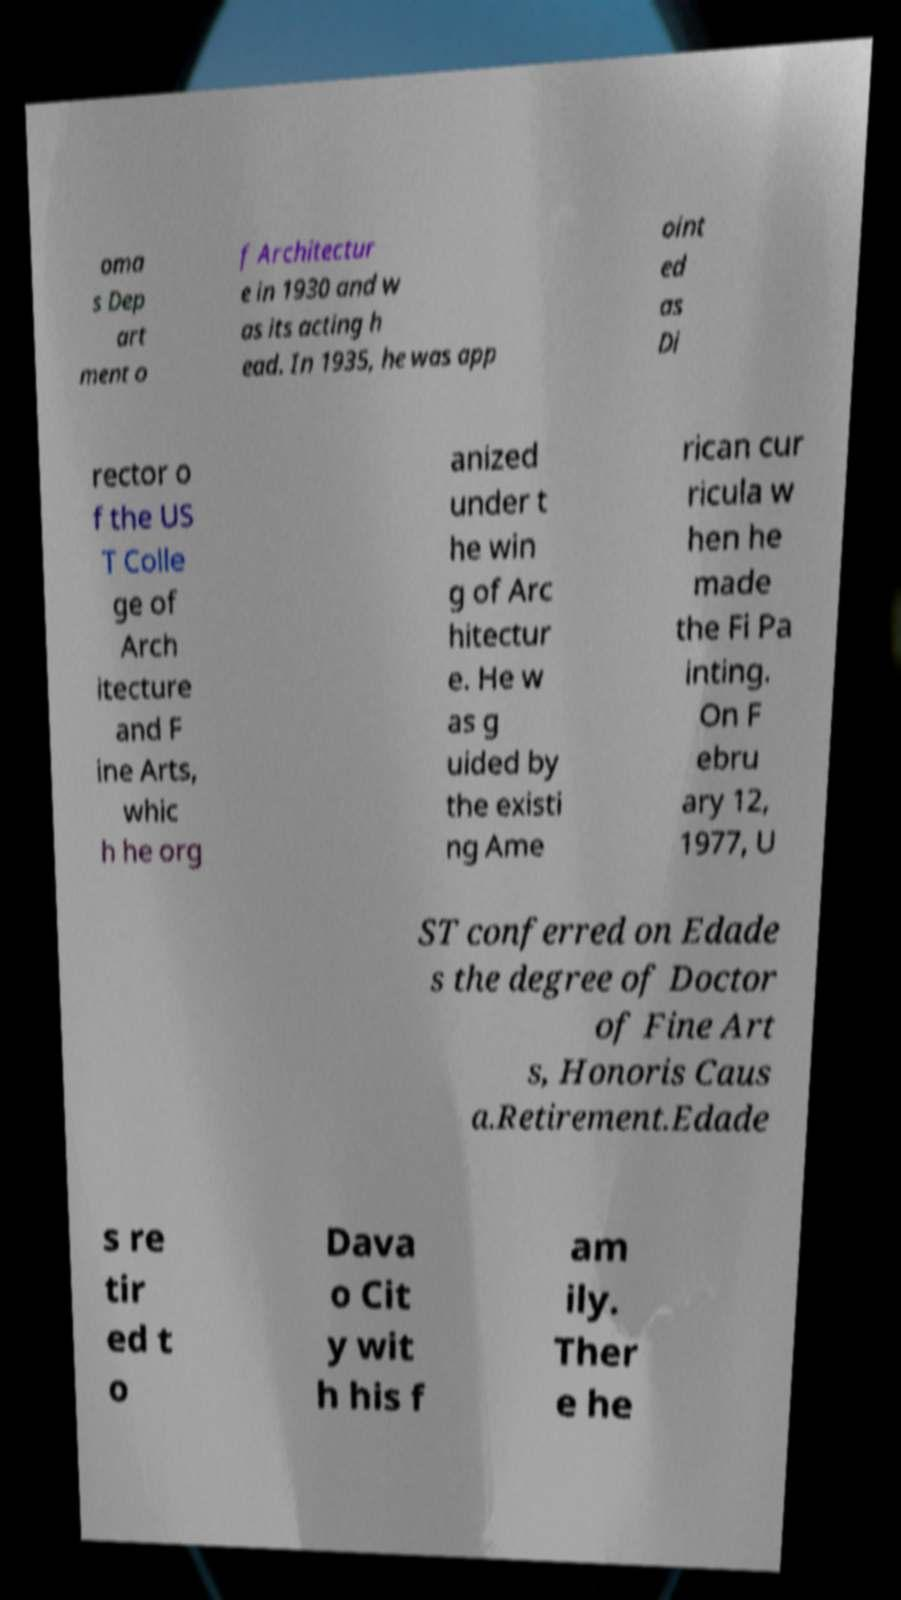There's text embedded in this image that I need extracted. Can you transcribe it verbatim? oma s Dep art ment o f Architectur e in 1930 and w as its acting h ead. In 1935, he was app oint ed as Di rector o f the US T Colle ge of Arch itecture and F ine Arts, whic h he org anized under t he win g of Arc hitectur e. He w as g uided by the existi ng Ame rican cur ricula w hen he made the Fi Pa inting. On F ebru ary 12, 1977, U ST conferred on Edade s the degree of Doctor of Fine Art s, Honoris Caus a.Retirement.Edade s re tir ed t o Dava o Cit y wit h his f am ily. Ther e he 